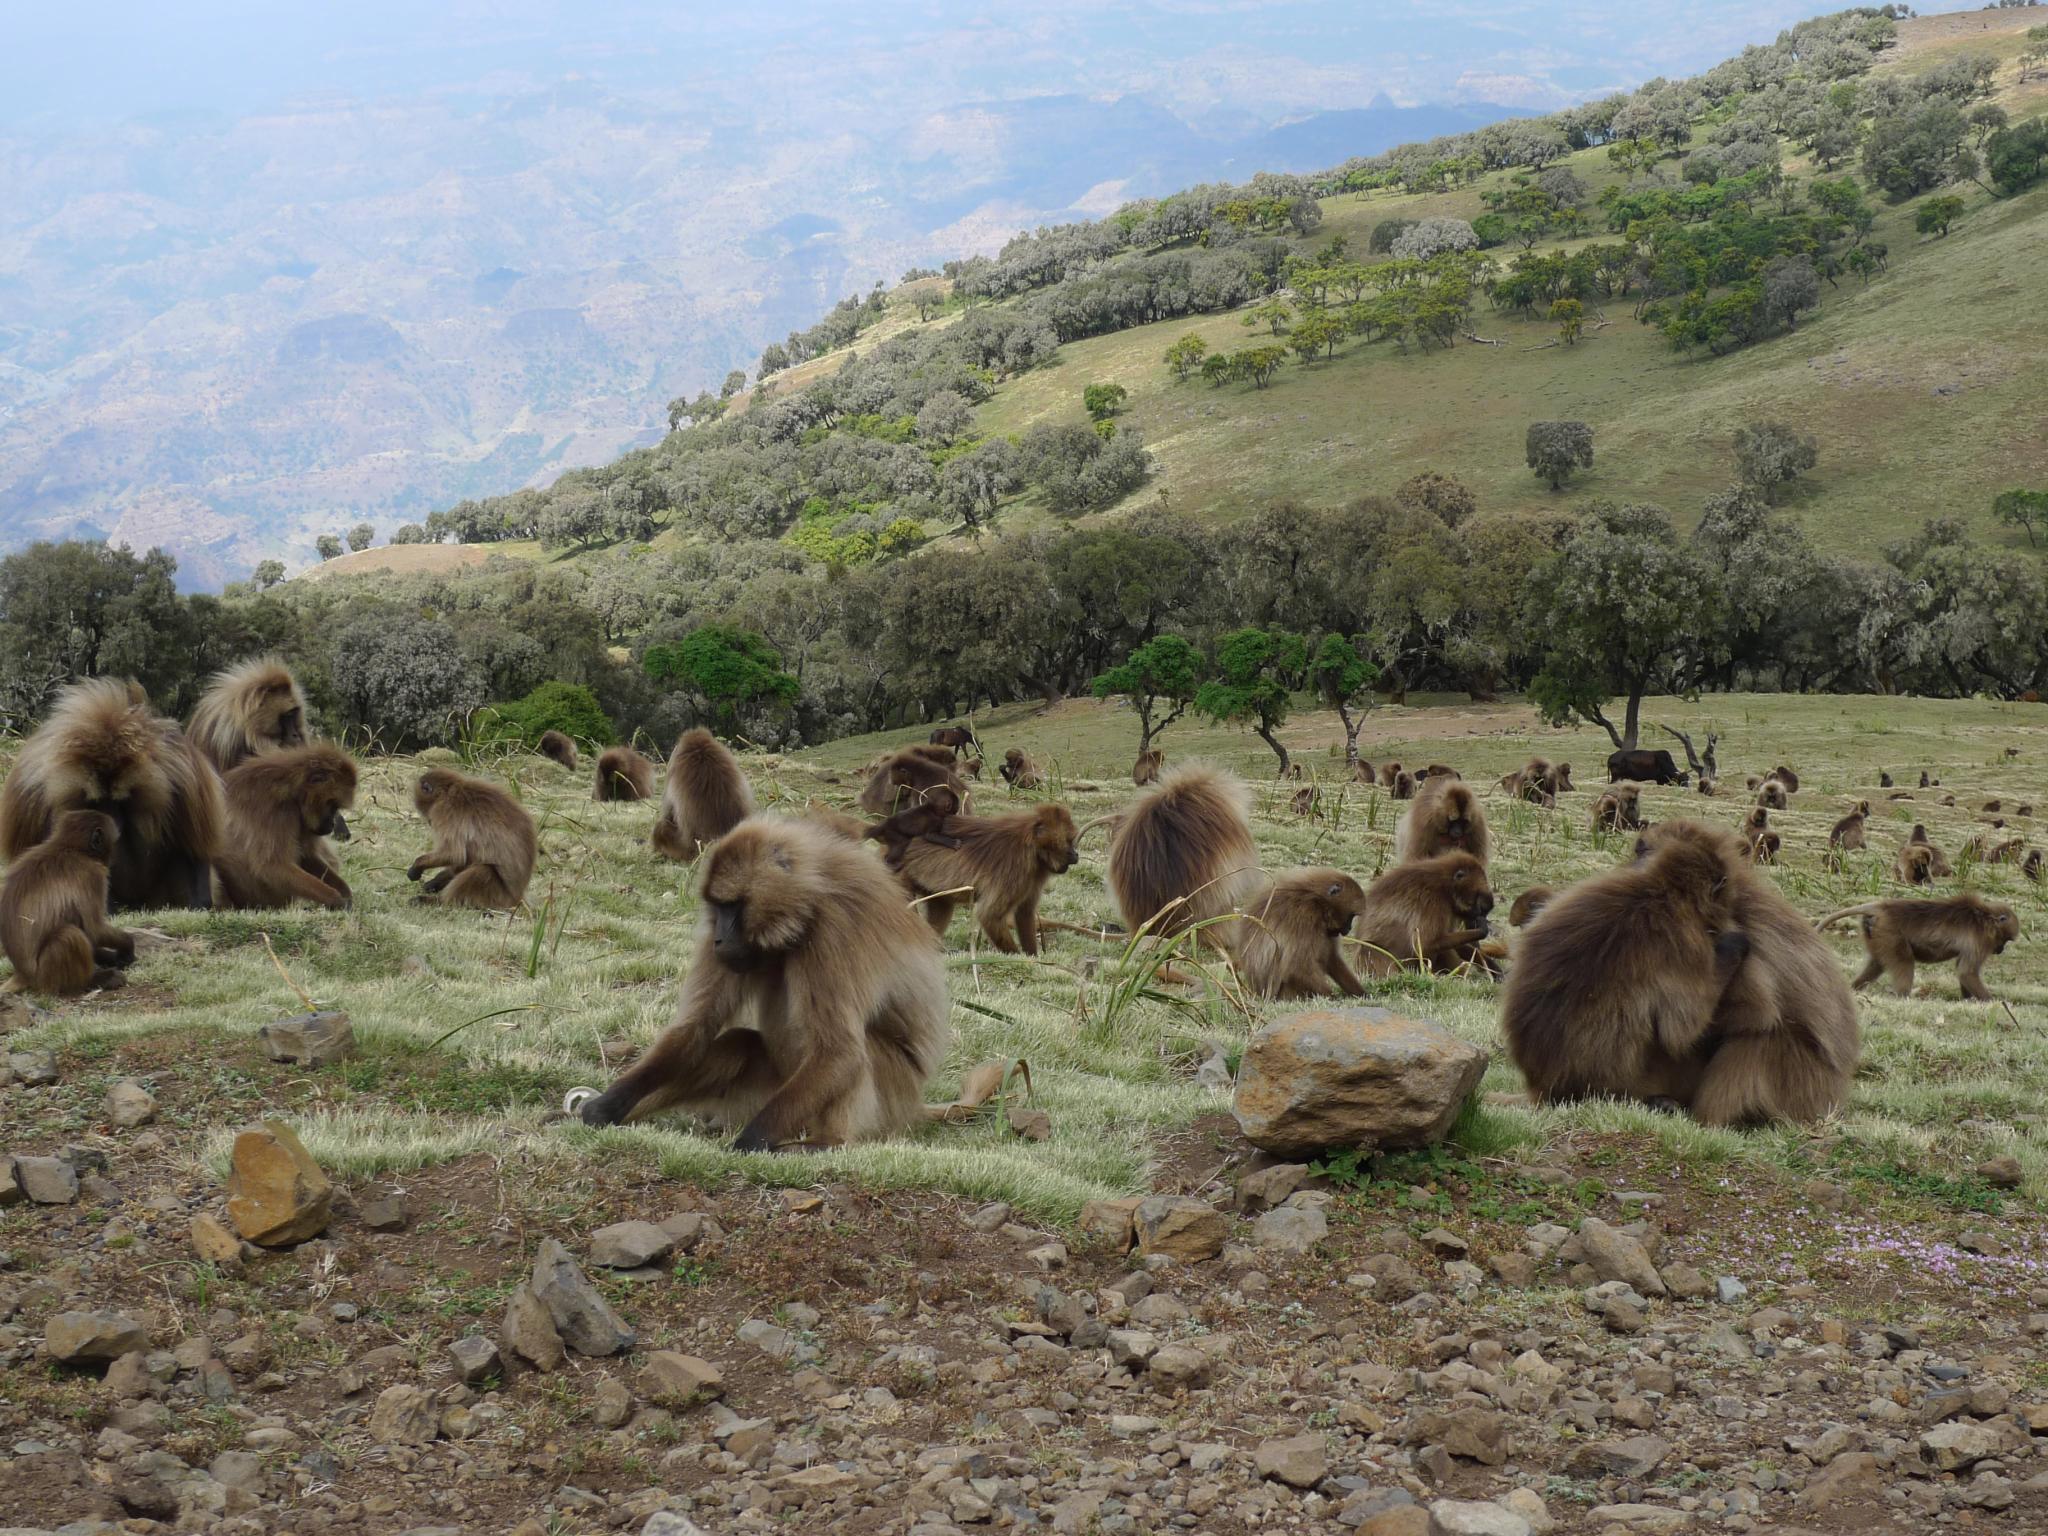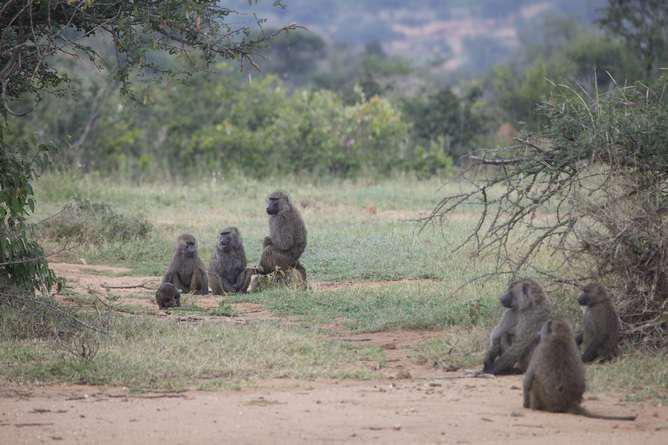The first image is the image on the left, the second image is the image on the right. Analyze the images presented: Is the assertion "All images feature monkeys sitting on grass." valid? Answer yes or no. Yes. The first image is the image on the left, the second image is the image on the right. Considering the images on both sides, is "An image shows baboons sitting in a green valley with many visible trees on the hillside behind them." valid? Answer yes or no. Yes. 